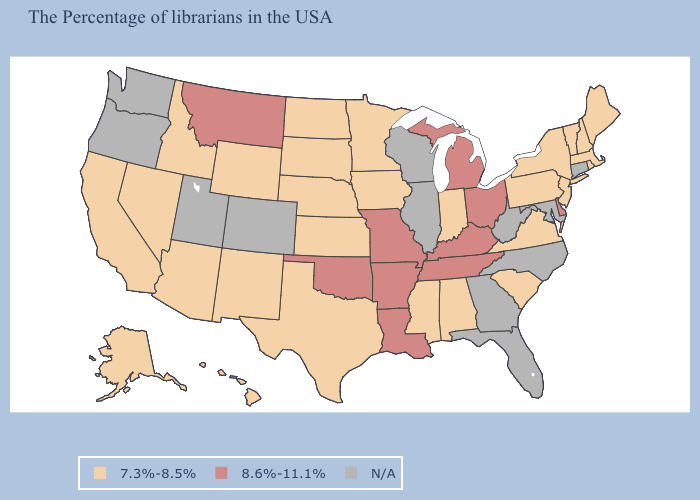Is the legend a continuous bar?
Keep it brief. No. What is the value of Delaware?
Keep it brief. 8.6%-11.1%. Which states hav the highest value in the South?
Be succinct. Delaware, Kentucky, Tennessee, Louisiana, Arkansas, Oklahoma. Name the states that have a value in the range 7.3%-8.5%?
Write a very short answer. Maine, Massachusetts, Rhode Island, New Hampshire, Vermont, New York, New Jersey, Pennsylvania, Virginia, South Carolina, Indiana, Alabama, Mississippi, Minnesota, Iowa, Kansas, Nebraska, Texas, South Dakota, North Dakota, Wyoming, New Mexico, Arizona, Idaho, Nevada, California, Alaska, Hawaii. What is the lowest value in the South?
Keep it brief. 7.3%-8.5%. Does the map have missing data?
Be succinct. Yes. What is the highest value in states that border Texas?
Write a very short answer. 8.6%-11.1%. Name the states that have a value in the range 7.3%-8.5%?
Answer briefly. Maine, Massachusetts, Rhode Island, New Hampshire, Vermont, New York, New Jersey, Pennsylvania, Virginia, South Carolina, Indiana, Alabama, Mississippi, Minnesota, Iowa, Kansas, Nebraska, Texas, South Dakota, North Dakota, Wyoming, New Mexico, Arizona, Idaho, Nevada, California, Alaska, Hawaii. What is the value of Washington?
Write a very short answer. N/A. What is the highest value in the Northeast ?
Answer briefly. 7.3%-8.5%. What is the lowest value in the USA?
Be succinct. 7.3%-8.5%. Does Ohio have the lowest value in the USA?
Answer briefly. No. 